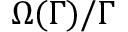<formula> <loc_0><loc_0><loc_500><loc_500>\Omega ( \Gamma ) / \Gamma</formula> 